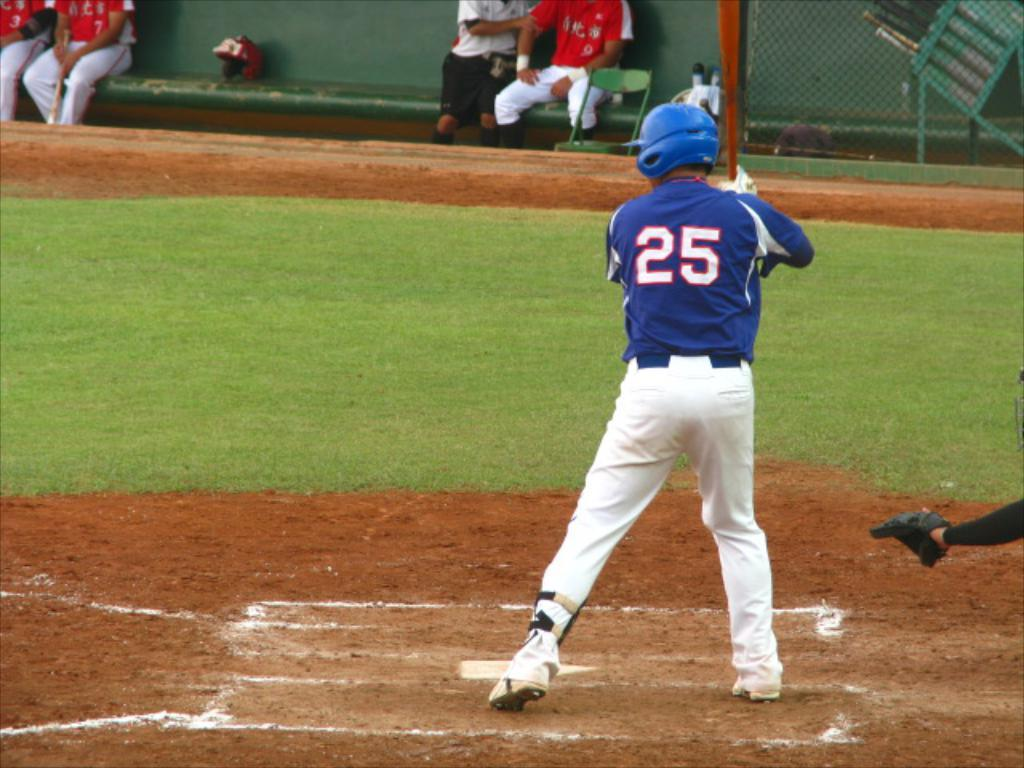<image>
Write a terse but informative summary of the picture. Batter number 25 at the plate getting ready to hit the ball. 